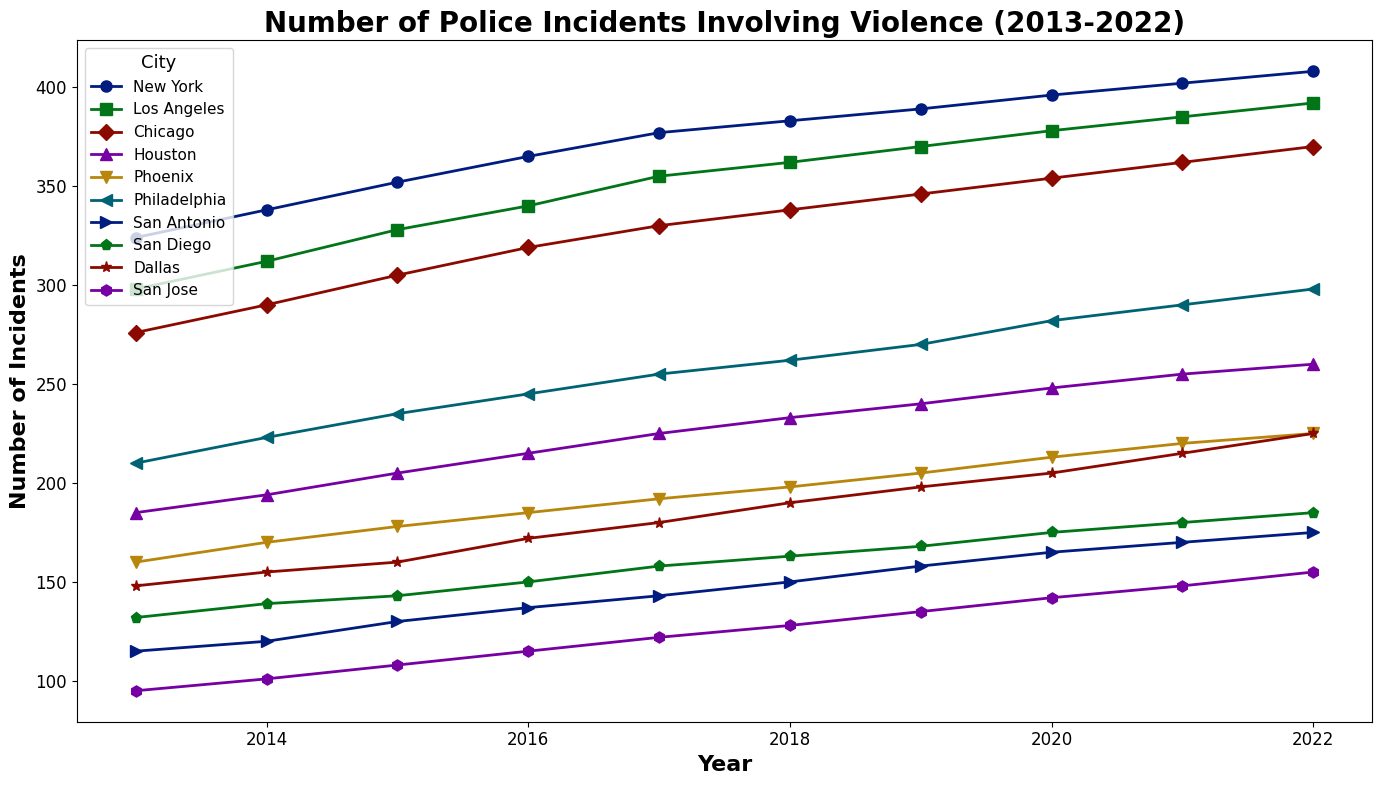What is the trend of police incidents involving violence in New York from 2013 to 2022? First, locate the line corresponding to New York. Observe the plot trend from 2013 to 2022 and note whether the line generally goes upwards, downwards, or remains stable.
Answer: Upward trend Which city had the highest number of police incidents involving violence in 2022? Identify the data points in 2022 and find the one with the highest value.
Answer: New York Which city shows the most significant increase in police incidents involving violence from 2013 to 2022? Compare the start and end points of each city's line. Calculate the difference for each city and determine the highest increase.
Answer: New York Which two cities had the most similar number of police incidents involving violence in 2017? Look at the data points for 2017 and identify the two cities with the closest values.
Answer: San Diego and San Jose What is the average annual number of police incidents involving violence in Chicago from 2013 to 2022? Add up the data points for Chicago from 2013 to 2022 and then divide by 10 (the number of years). (276 + 290 + 305 + 319 + 330 + 338 + 346 + 354 + 362 + 370) / 10 = 331
Answer: 331 Did Los Angeles or Dallas experience a more significant percentage increase from 2013 to 2022? Calculate the percentage increase for each city using ((End_Value - Start_Value) / Start_Value) * 100. For Los Angeles: ((392 - 298) / 298) * 100 ≈ 31.54%. For Dallas: ((225 - 148) / 148) * 100 ≈ 52.03%. Compare the two percentages.
Answer: Dallas Which city had the least number of police incidents involving violence in any year, and what was that number? Identify the lowest data point across all years and all cities.
Answer: San Jose, 95 From 2013 to 2022, which city shows the most stable trend (least variation) in the number of police incidents involving violence? Compare the fluctuations in the line plots for each city to identify the most stable trend.
Answer: San Antonio In which year did San Diego experience the highest number of police incidents involving violence? Focus on the line for San Diego and identify the peak point.
Answer: 2022 How does the number of police incidents involving violence in Phoenix in 2020 compare to the average of the same city from 2013 to 2022? Calculate the average for Phoenix from 2013 to 2022: (160 + 170 + 178 + 185 + 192 + 198 + 205 + 213 + 220 + 225) / 10 = 194. Observe the value for Phoenix in 2020, which is 213. Compare the two values.
Answer: Higher 